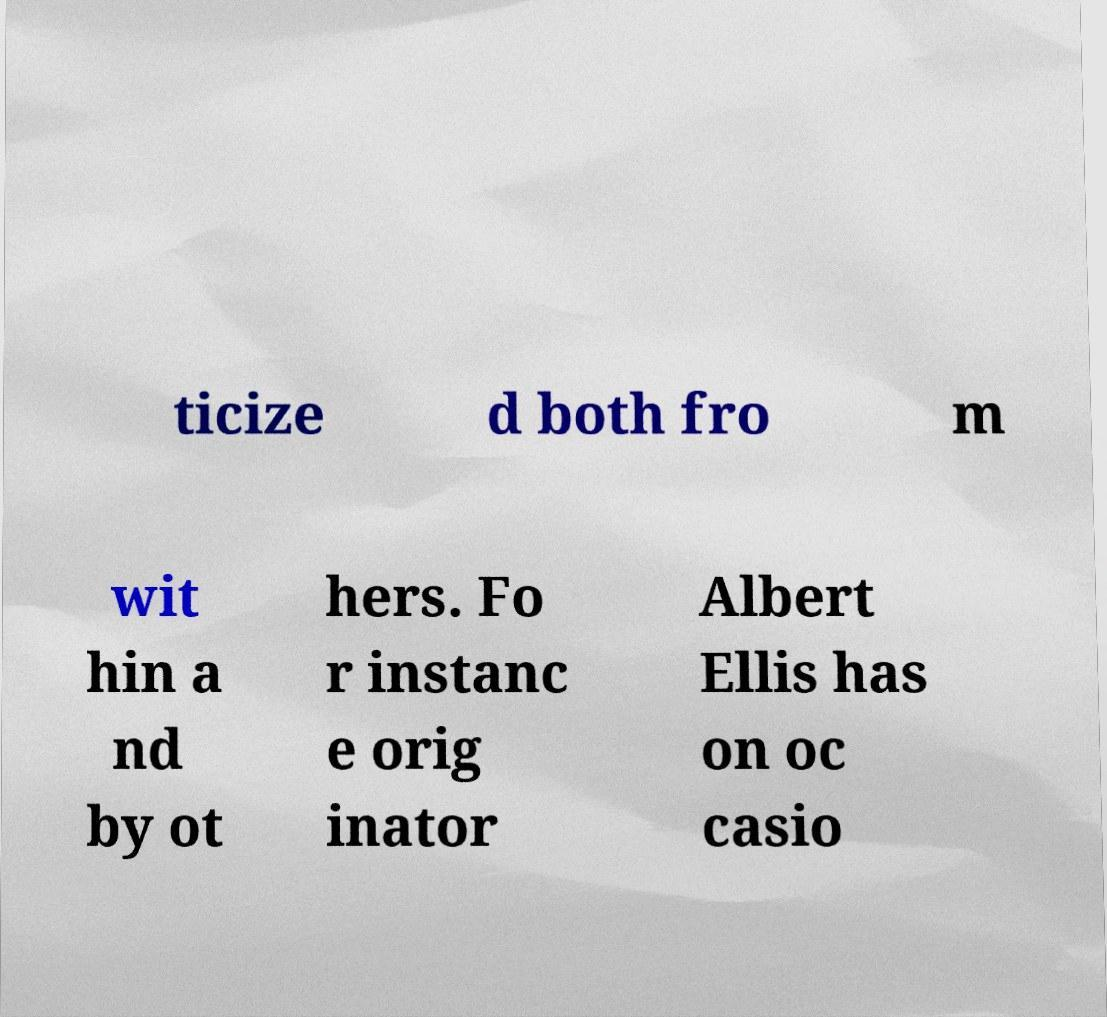Can you accurately transcribe the text from the provided image for me? ticize d both fro m wit hin a nd by ot hers. Fo r instanc e orig inator Albert Ellis has on oc casio 